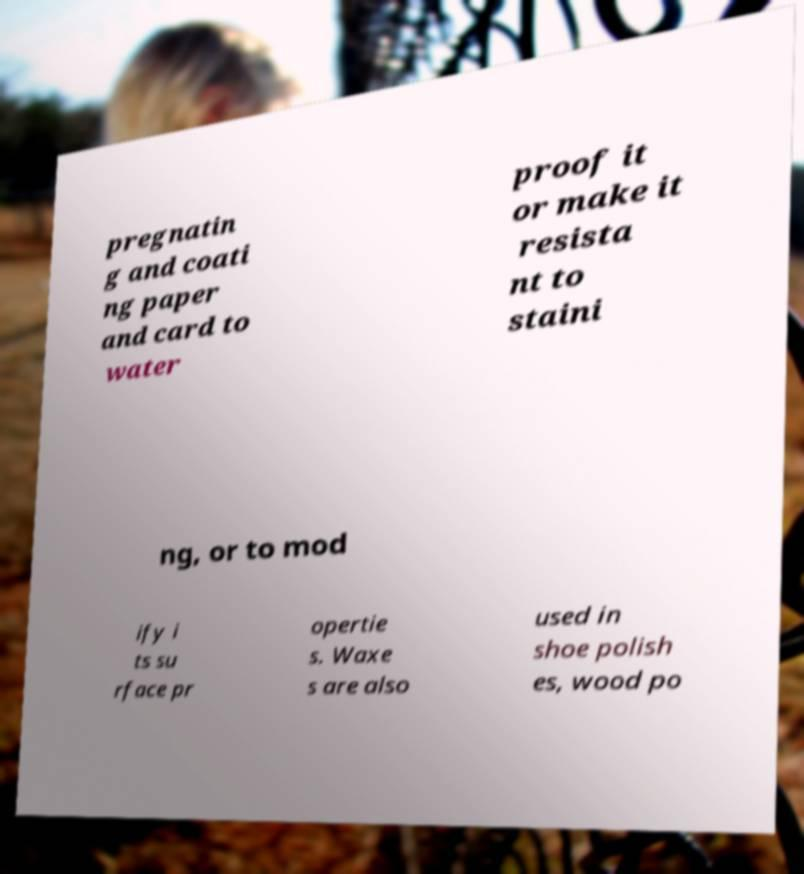There's text embedded in this image that I need extracted. Can you transcribe it verbatim? pregnatin g and coati ng paper and card to water proof it or make it resista nt to staini ng, or to mod ify i ts su rface pr opertie s. Waxe s are also used in shoe polish es, wood po 